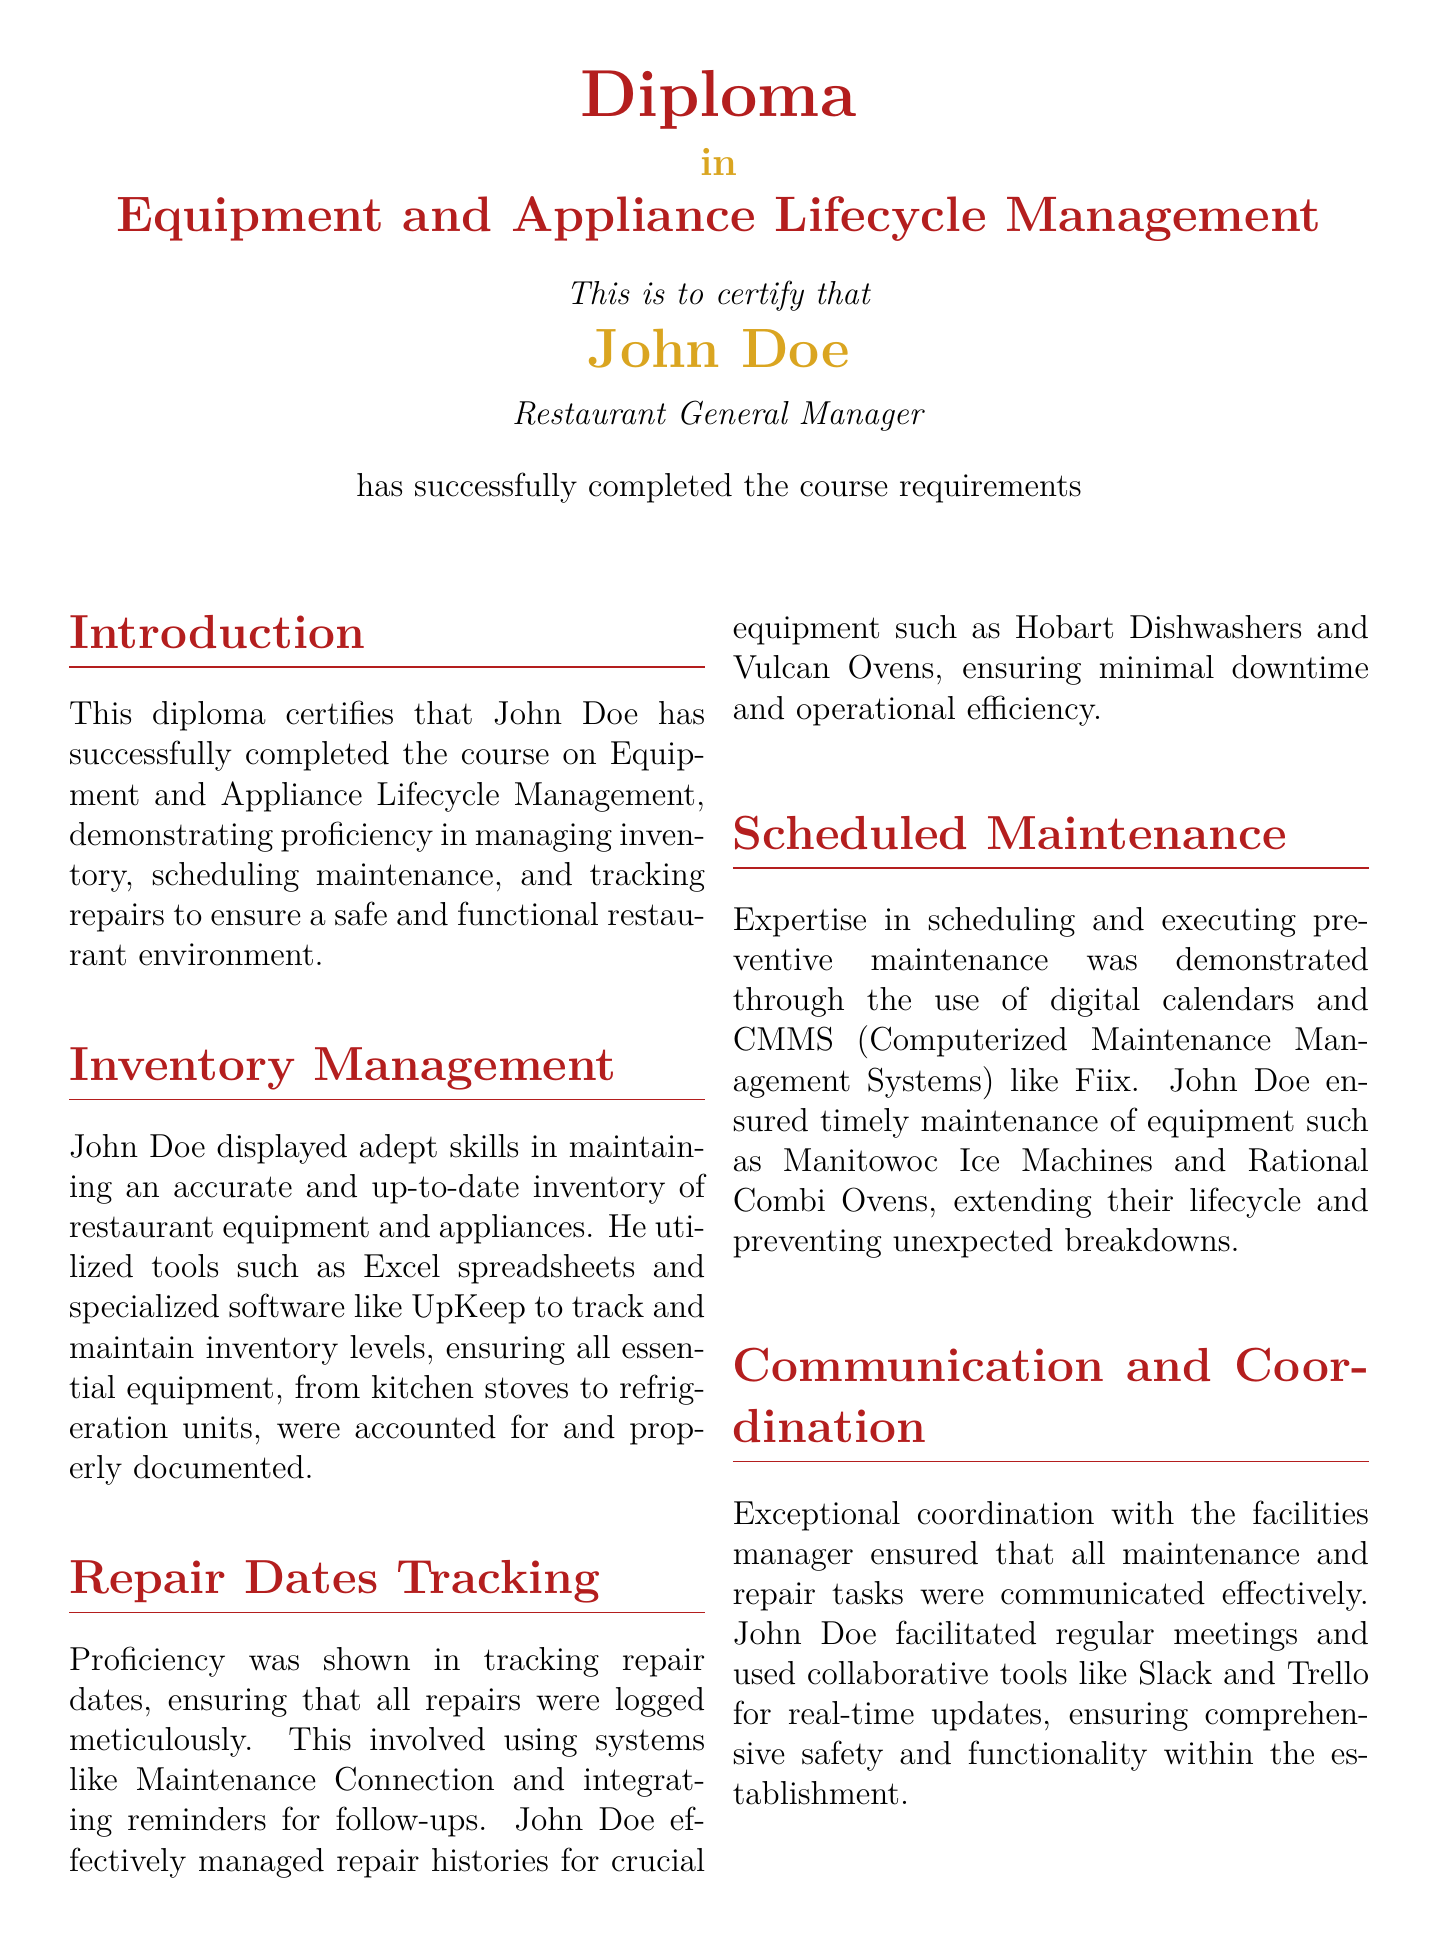What is the name of the individual receiving the diploma? The diploma certifies that John Doe has completed the course requirements.
Answer: John Doe What is the title of the diploma? The document indicates the title of the diploma as Equipment and Appliance Lifecycle Management.
Answer: Equipment and Appliance Lifecycle Management When was the diploma issued? The issuance date mentioned in the document is December 15, 2023.
Answer: December 15, 2023 Which management systems did John Doe utilize for scheduling maintenance? The document highlights John Doe's use of CMMS like Fiix for scheduling maintenance.
Answer: Fiix What essential kitchen equipment was specifically mentioned in repair tracking? The document refers to Hobart Dishwashers as crucial equipment in the repair tracking section.
Answer: Hobart Dishwashers How did John Doe demonstrate coordination with the facilities manager? John Doe facilitated regular meetings and used collaborative tools like Slack and Trello.
Answer: Slack and Trello What institution issued the diploma? The document states that the diploma was issued by the Hospitality Management Institute.
Answer: Hospitality Management Institute What was emphasized in the scheduled maintenance section of the diploma? The scheduled maintenance section emphasizes timely maintenance of equipment.
Answer: Timely maintenance How did John Doe ensure operational efficiency regarding repairs? The document mentions that he ensured minimal downtime and operational efficiency.
Answer: Minimal downtime 